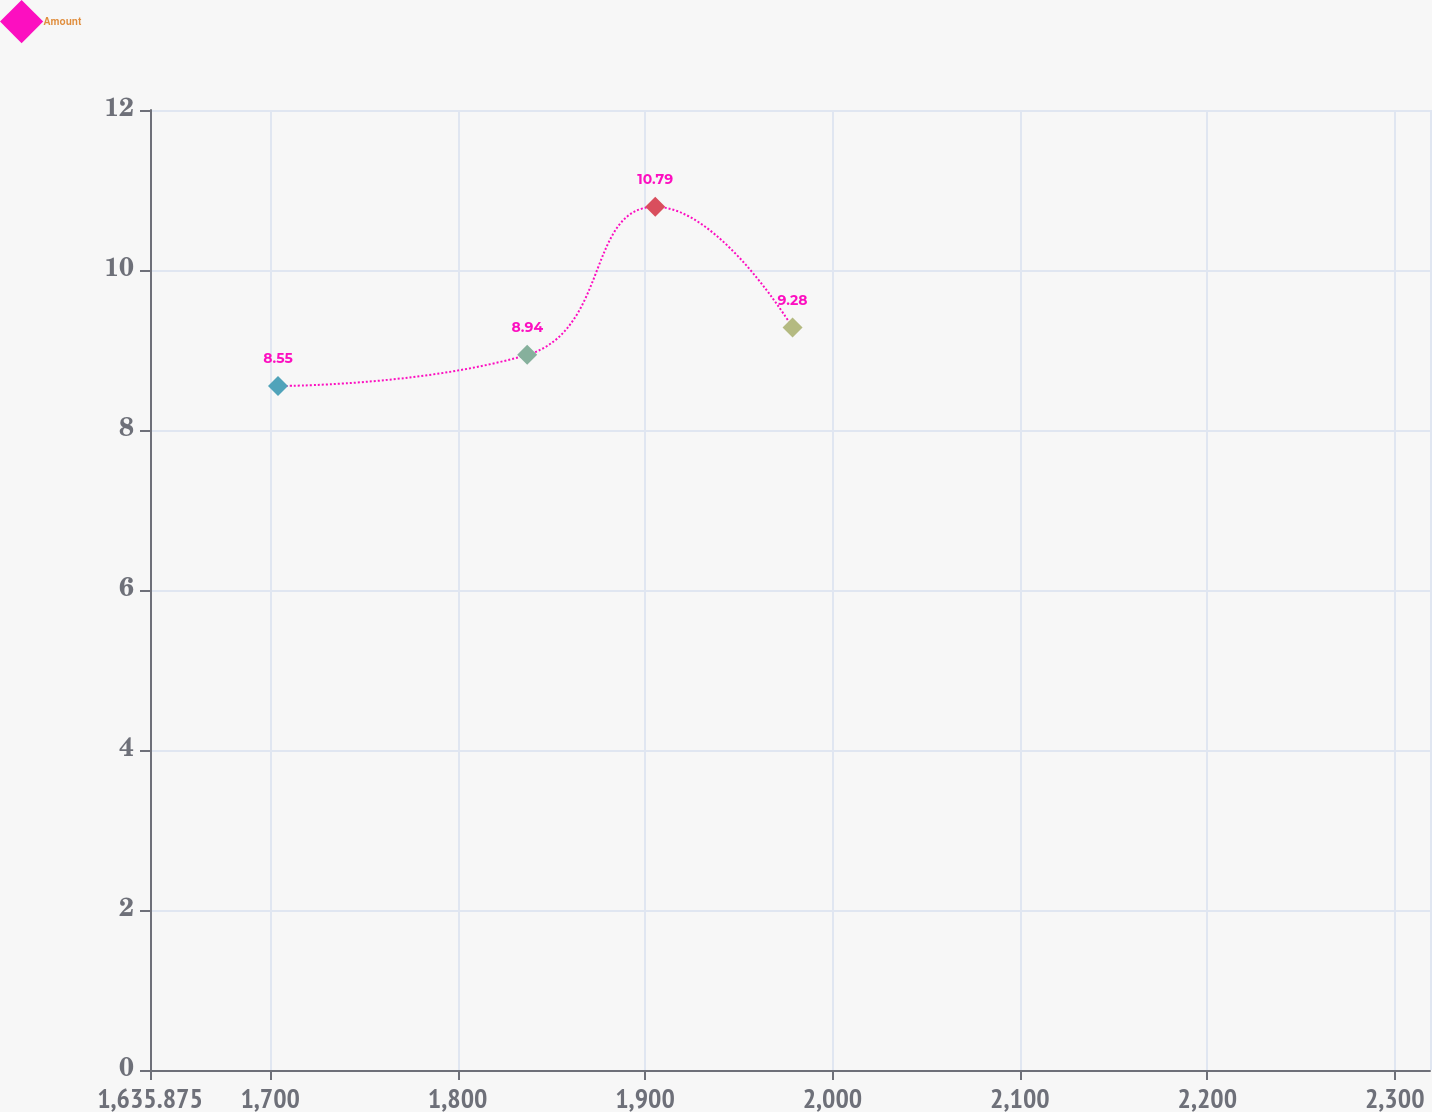Convert chart. <chart><loc_0><loc_0><loc_500><loc_500><line_chart><ecel><fcel>Amount<nl><fcel>1704.17<fcel>8.55<nl><fcel>1837.14<fcel>8.94<nl><fcel>1905.44<fcel>10.79<nl><fcel>1978.72<fcel>9.28<nl><fcel>2387.12<fcel>10.07<nl></chart> 